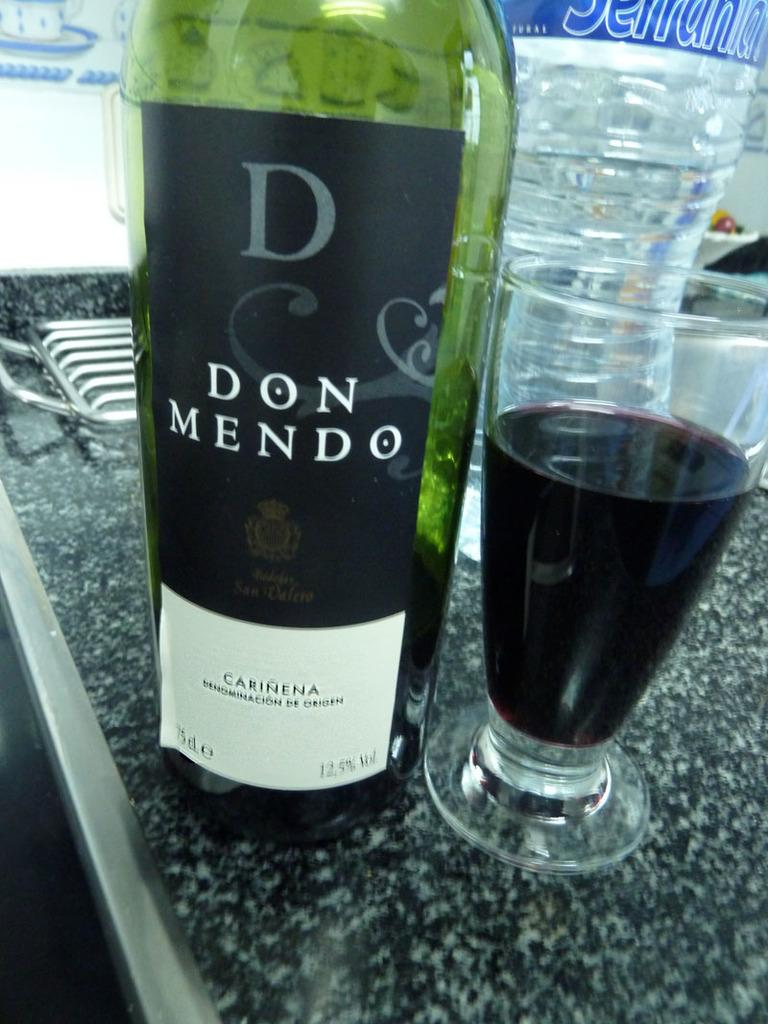<image>
Render a clear and concise summary of the photo. A bottle of Don Mendo Carinena is sitting on a counter next to a glass. 